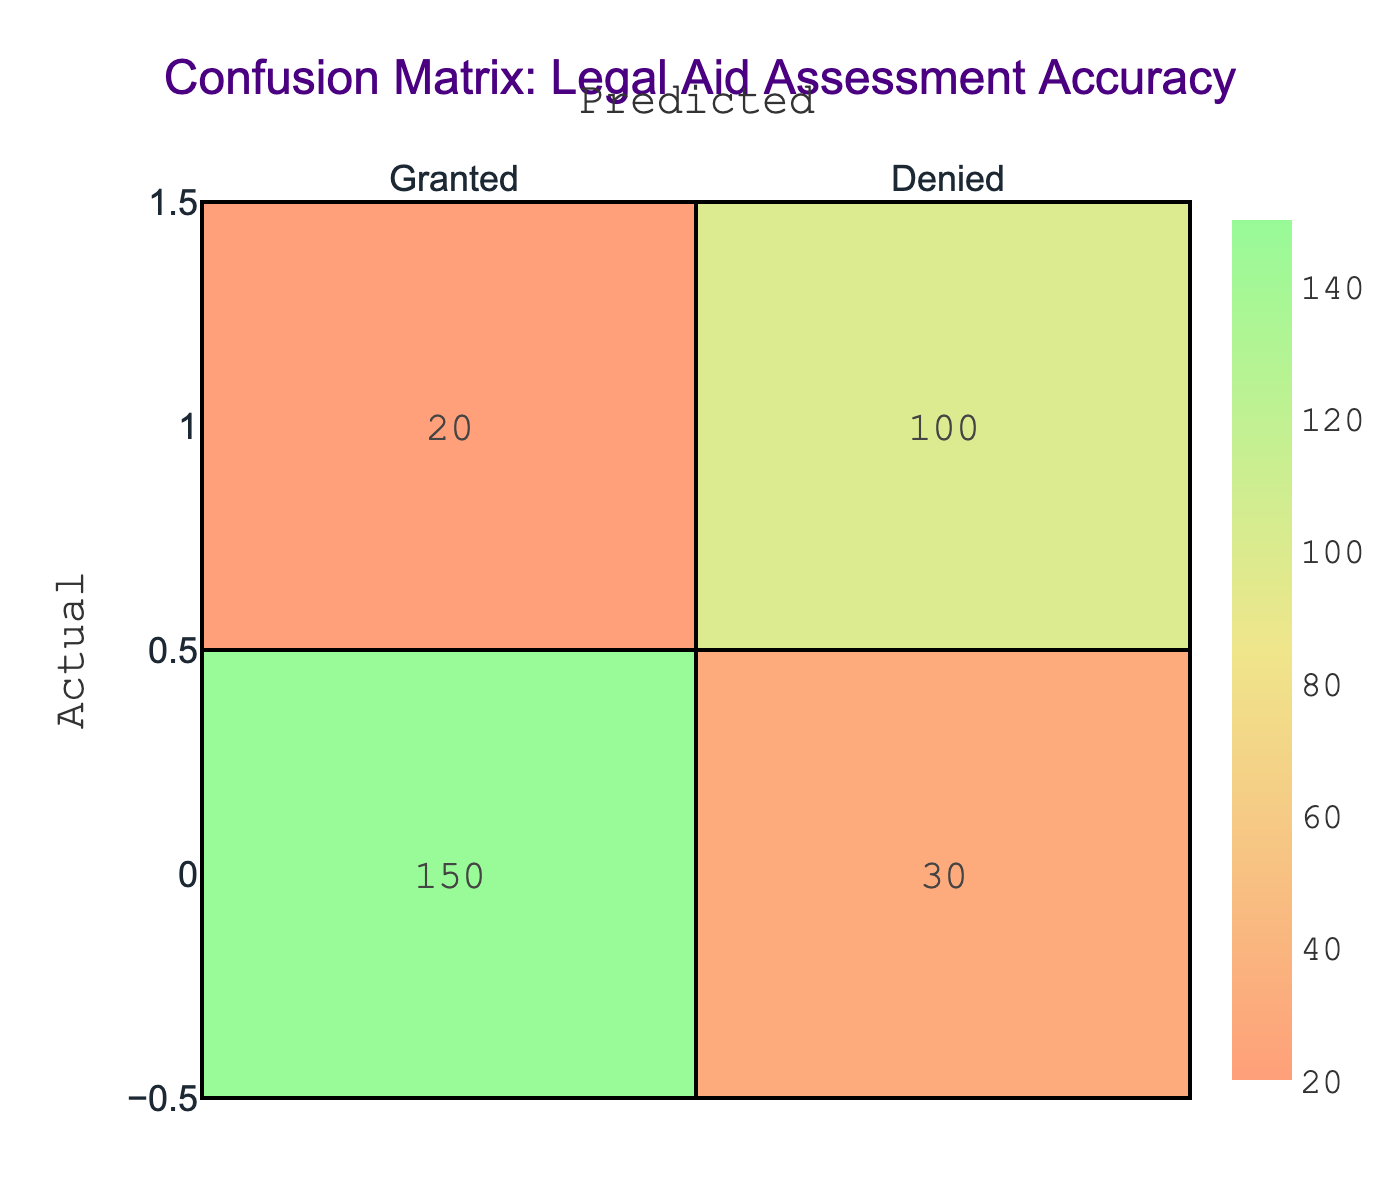What is the total number of cases that were granted legal aid? In the table, the number of cases granted legal aid is represented in the first row under the 'Granted' column. The value is 150.
Answer: 150 What is the total number of cases that were denied legal aid? The total number of cases denied legal aid can be found in the second row under the 'Denied' column. The value is 100.
Answer: 100 How many cases were incorrectly assessed as denied when they should have been granted? The number of cases that were incorrectly assessed is found in the first row under the 'Denied' column, which lists the value 30.
Answer: 30 What proportion of the total cases were denied legal aid? To find the proportion denied, we total all cases (150 + 30 + 20 + 100 = 300) and divide the number of denied cases (100) by this total: 100/300 = 1/3 = 0.33.
Answer: 0.33 How many cases were correctly assessed in total? The correctly assessed cases are the sum of the true positives (150) and the true negatives (100). Adding them gives 150 + 100 = 250.
Answer: 250 Is it true that a majority of the cases were granted legal aid? We total the cases again (150 + 30 + 20 + 100 = 300) and see that granted cases (150) are less than denied cases (100); thus, it is not true.
Answer: No What is the error rate for incorrect legal aid assessments? The error rate can be calculated by finding the total incorrect assessments (false positives + false negatives = 30 + 20 = 50) and dividing by the total cases (300): 50/300 = 1/6 = 0.17.
Answer: 0.17 If we combine the cases granted and denied, what percentage of total cases granted legal aid represents? The total granted cases (150) divide into the total cases (300): (150/300) * 100 = 50%.
Answer: 50% What is the ratio of cases granted legally to denied cases? The ratio of granted to denied cases can be determined from the table values; it is 150 (granted) to 100 (denied), which simplifies to 3:2.
Answer: 3:2 